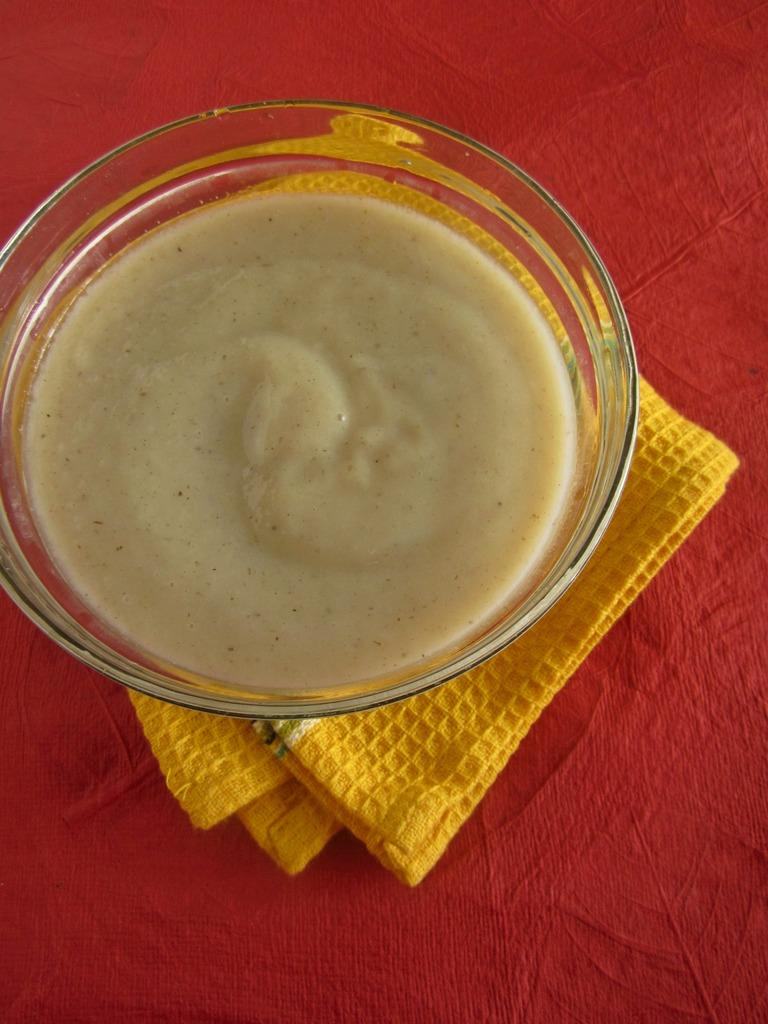What is inside the glass bowl in the image? There is food inside the glass bowl in the image. What is the color of the surface beneath the glass bowl? The surface beneath the glass bowl is red in color. What other color can be seen in the image besides red? There is a yellow color cloth in the image. How far away is the grass from the glass bowl in the image? There is no grass present in the image, so it is not possible to determine the distance between the glass bowl and any grass. 